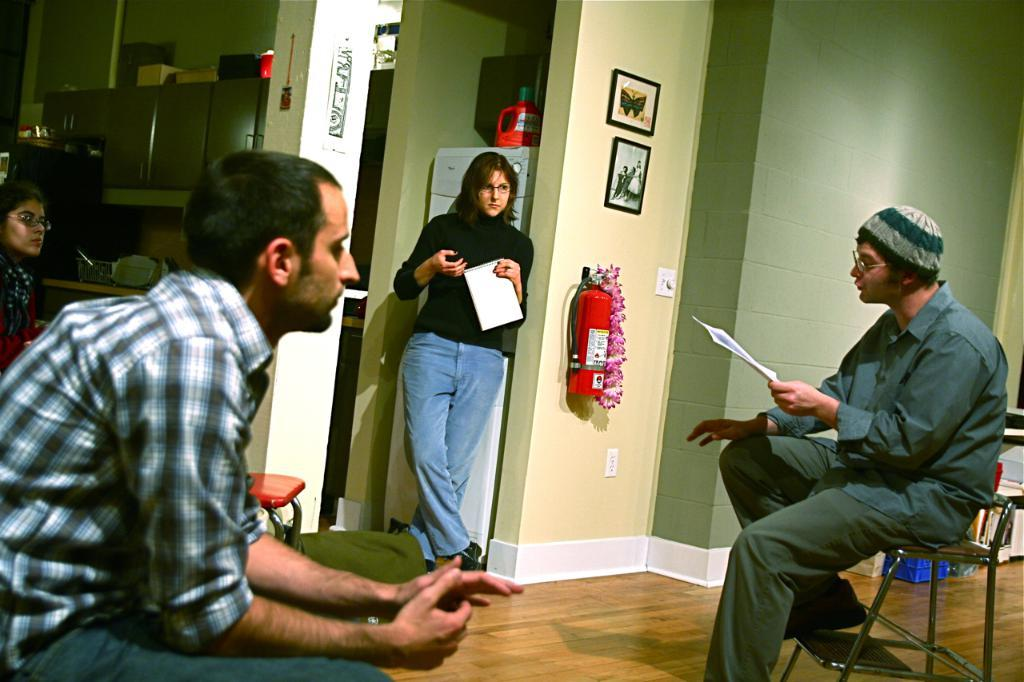What are the people in the image doing? The people in the image are sitting on chairs. Can you describe the woman in the image? There is a woman standing in the image. What is the woman holding in her hand? The woman is holding a paper in her hand. What type of art can be seen on the woman's face in the image? There is no art or any indication of a face on the woman in the image. How many grandmothers are present in the image? There is no mention of a grandmother or any elderly woman in the image. 